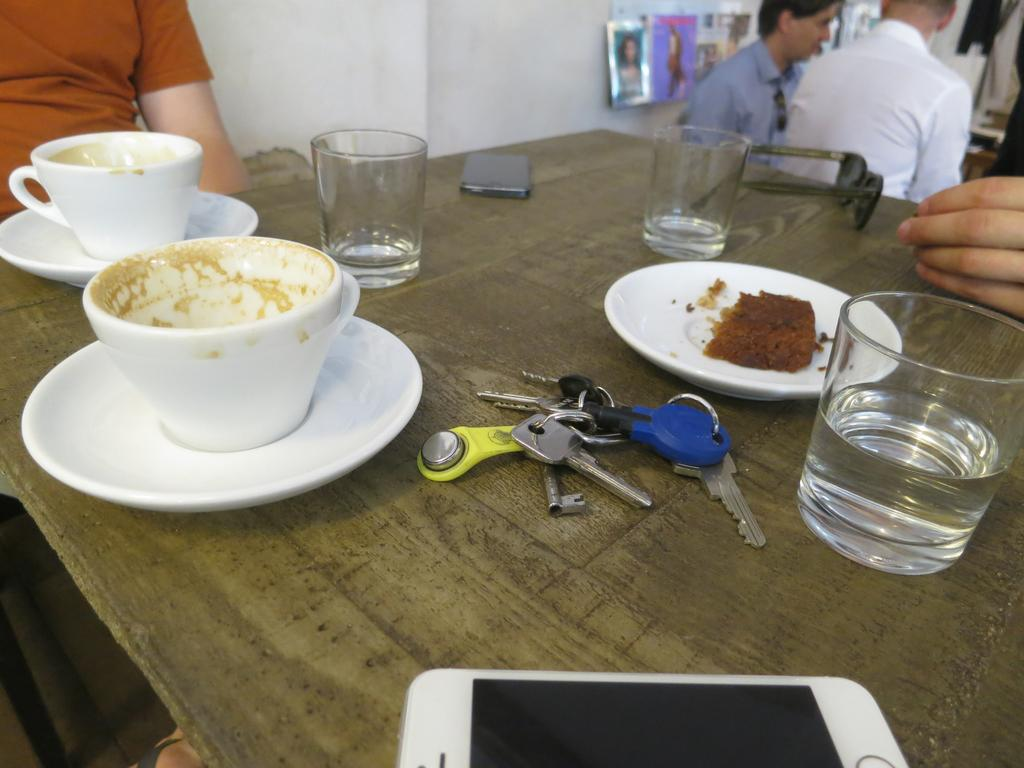What objects are on the table in the image? There are glasses, keys, a mobile, plates, cups, and food on the table in the image. What else can be seen in the image besides the table? There are persons sitting on chairs and posters on the wall in the image. How many objects are on the table? There are at least seven objects on the table: glasses, keys, a mobile, plates, cups, and food. What type of design is featured on the jail cell in the image? There is no jail cell present in the image; it features a table with various objects and persons sitting on chairs. 